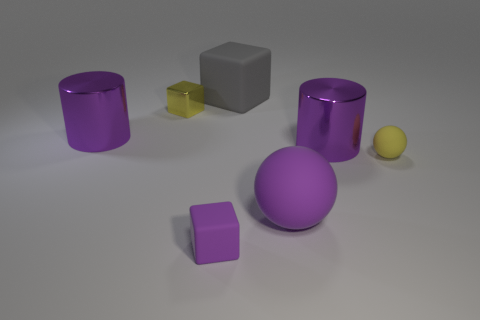Subtract all green spheres. Subtract all purple cylinders. How many spheres are left? 2 Add 2 small yellow matte balls. How many objects exist? 9 Subtract all cylinders. How many objects are left? 5 Subtract 0 red cubes. How many objects are left? 7 Subtract all large blue shiny balls. Subtract all gray cubes. How many objects are left? 6 Add 3 tiny metal things. How many tiny metal things are left? 4 Add 2 tiny brown shiny objects. How many tiny brown shiny objects exist? 2 